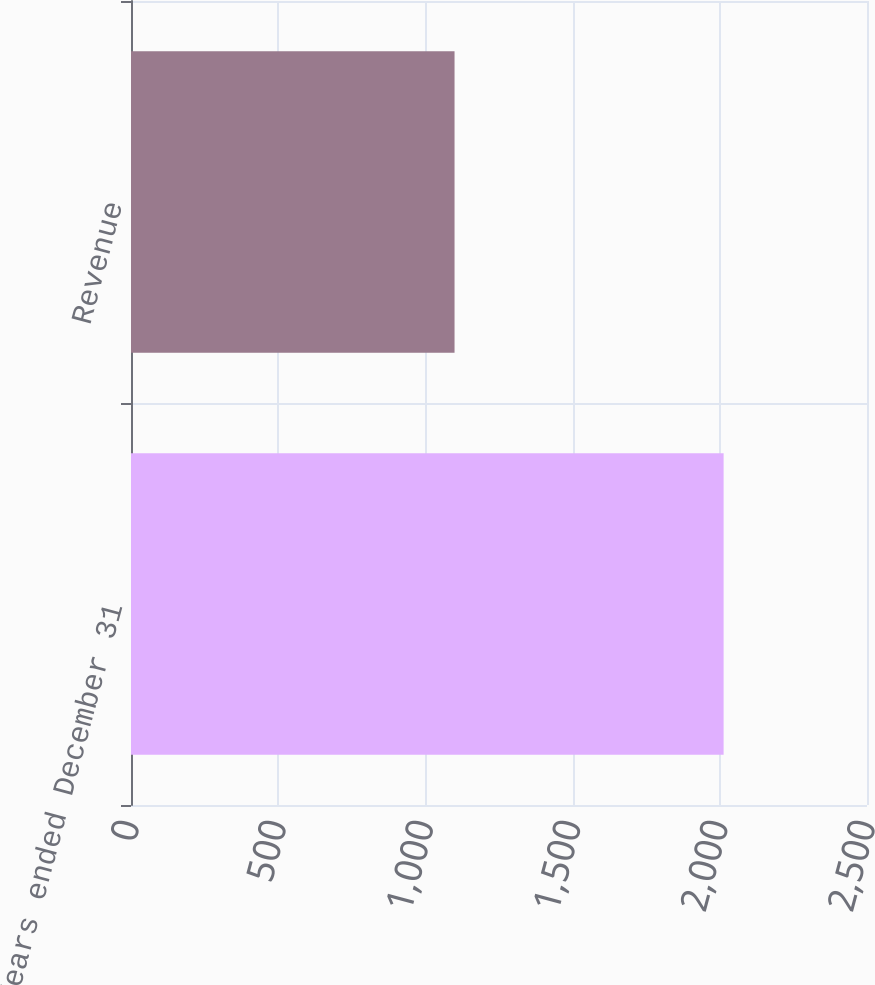<chart> <loc_0><loc_0><loc_500><loc_500><bar_chart><fcel>Years ended December 31<fcel>Revenue<nl><fcel>2013<fcel>1099<nl></chart> 